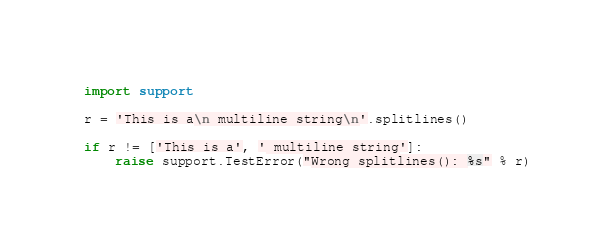Convert code to text. <code><loc_0><loc_0><loc_500><loc_500><_Python_>import support

r = 'This is a\n multiline string\n'.splitlines()

if r != ['This is a', ' multiline string']:
    raise support.TestError("Wrong splitlines(): %s" % r)

</code> 